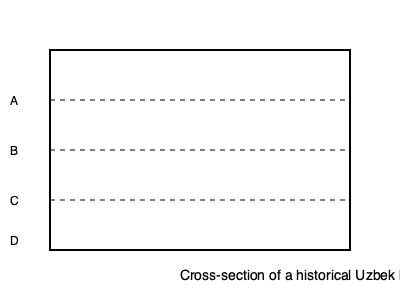In the cross-section drawing of a historical Uzbek building wall, identify the layer that most likely represents baked bricks, a common material in Timurid-era architecture. To identify the layer representing baked bricks in this cross-section of a historical Uzbek building wall, let's analyze each layer:

1. Layer A (top layer): This thin layer likely represents plaster or decorative finishing, which was commonly used to protect and beautify the walls.

2. Layer B: This substantial layer is most likely to represent baked bricks. Baked bricks were a primary building material in Timurid-era architecture, known for their durability and strength. They were typically used for the main body of the wall.

3. Layer C: This layer appears to be thicker than layer B and might represent a foundation layer or an earlier construction phase, possibly made of stone or compacted earth.

4. Layer D (bottom layer): This layer likely represents the building's foundation, possibly made of compacted earth or rubble.

Baked bricks were favored in Timurid architecture for several reasons:
- They were more durable than sun-dried bricks
- They allowed for more complex and taller structures
- They were suitable for creating decorative patterns and intricate designs

Given the characteristics of baked bricks and their importance in Uzbek historical architecture, layer B is the most probable representation of baked bricks in this cross-section.
Answer: Layer B 